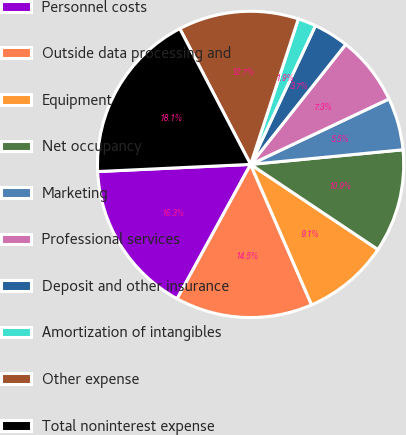Convert chart to OTSL. <chart><loc_0><loc_0><loc_500><loc_500><pie_chart><fcel>Personnel costs<fcel>Outside data processing and<fcel>Equipment<fcel>Net occupancy<fcel>Marketing<fcel>Professional services<fcel>Deposit and other insurance<fcel>Amortization of intangibles<fcel>Other expense<fcel>Total noninterest expense<nl><fcel>16.29%<fcel>14.49%<fcel>9.1%<fcel>10.9%<fcel>5.51%<fcel>7.3%<fcel>3.71%<fcel>1.91%<fcel>12.7%<fcel>18.09%<nl></chart> 